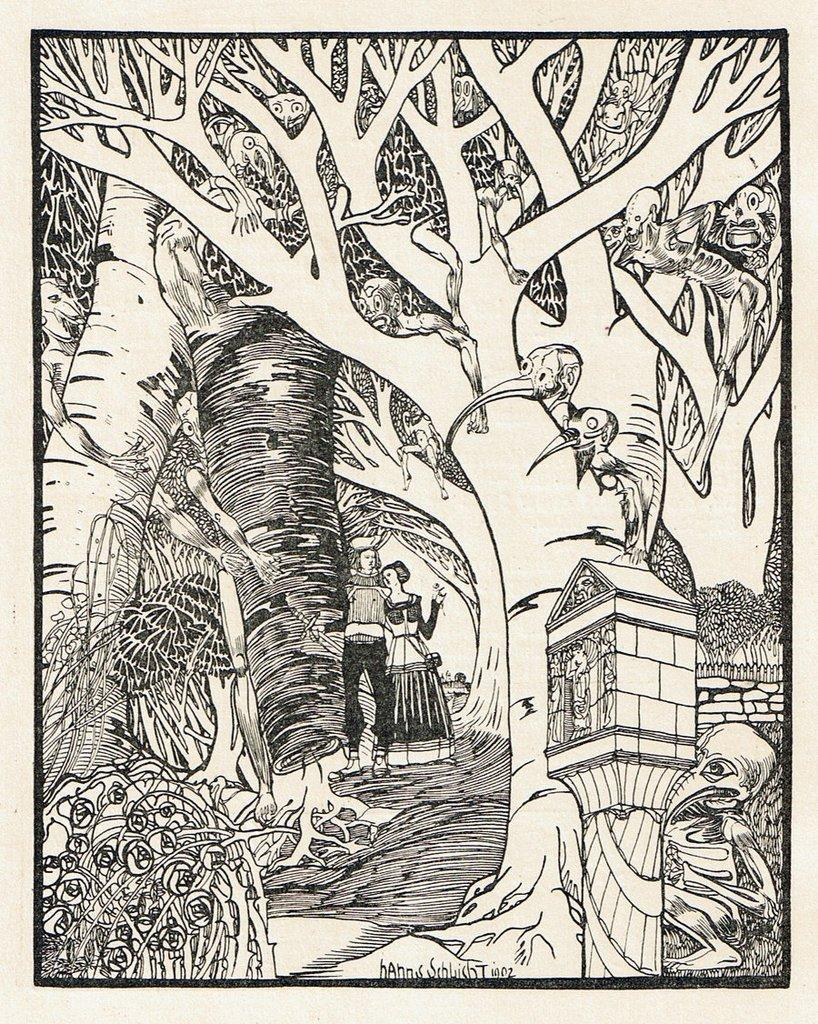What type of art is depicted in the image? The image contains an art piece. What is the subject matter of the art piece? The art piece features monsters and trees. Are there any people present in the image? Yes, there are persons in the middle of the image. How many yaks can be seen in the image? There are no yaks present in the image. What is the scale of the art piece in the image? The provided facts do not mention the scale of the art piece, so it cannot be determined from the image. 